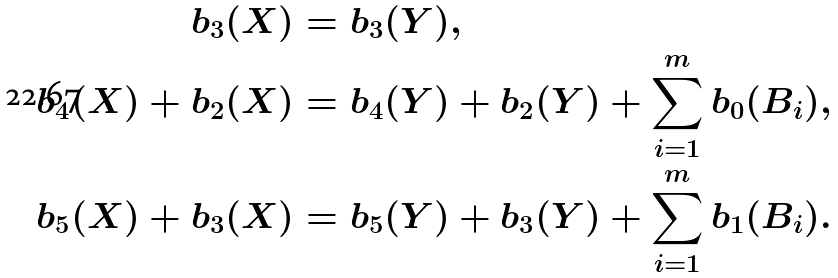<formula> <loc_0><loc_0><loc_500><loc_500>b _ { 3 } ( X ) & = b _ { 3 } ( Y ) , \\ b _ { 4 } ( X ) + b _ { 2 } ( X ) & = b _ { 4 } ( Y ) + b _ { 2 } ( Y ) + \sum _ { i = 1 } ^ { m } b _ { 0 } ( B _ { i } ) , \\ b _ { 5 } ( X ) + b _ { 3 } ( X ) & = b _ { 5 } ( Y ) + b _ { 3 } ( Y ) + \sum _ { i = 1 } ^ { m } b _ { 1 } ( B _ { i } ) .</formula> 